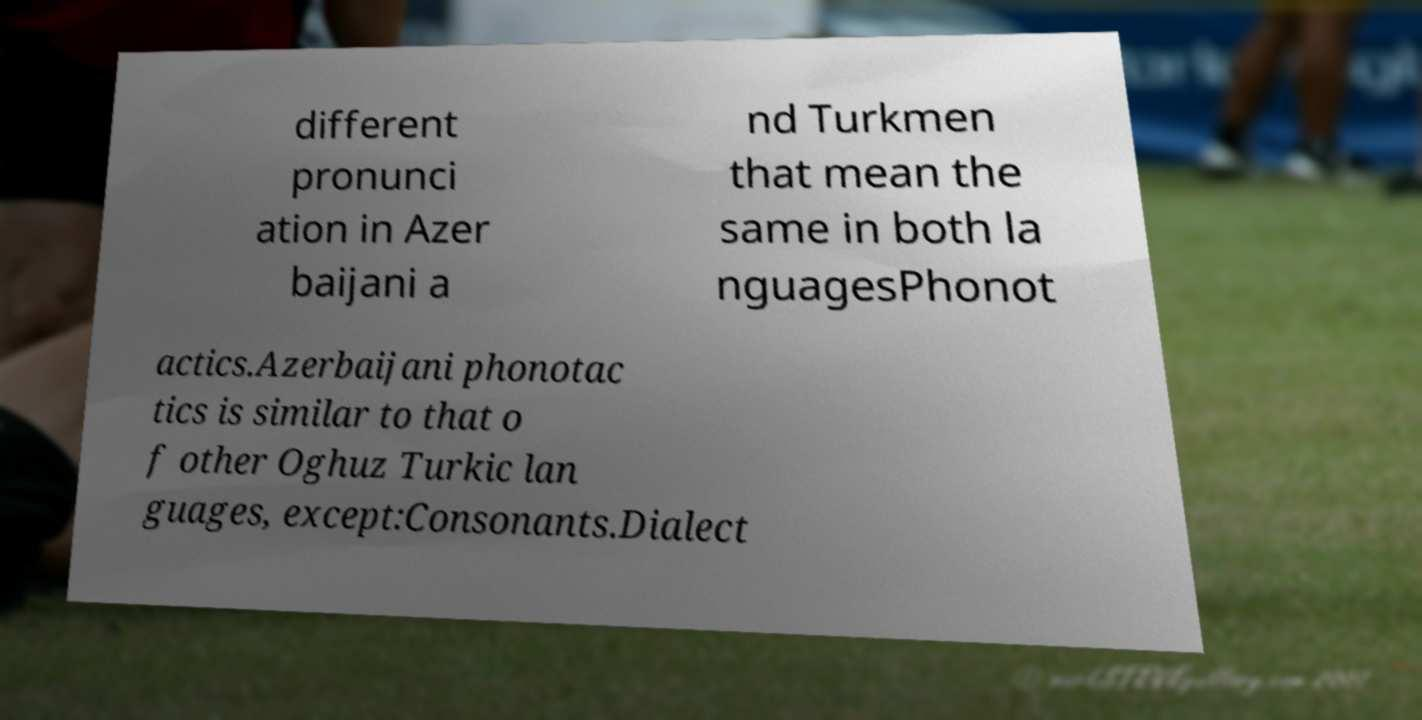Can you read and provide the text displayed in the image?This photo seems to have some interesting text. Can you extract and type it out for me? different pronunci ation in Azer baijani a nd Turkmen that mean the same in both la nguagesPhonot actics.Azerbaijani phonotac tics is similar to that o f other Oghuz Turkic lan guages, except:Consonants.Dialect 